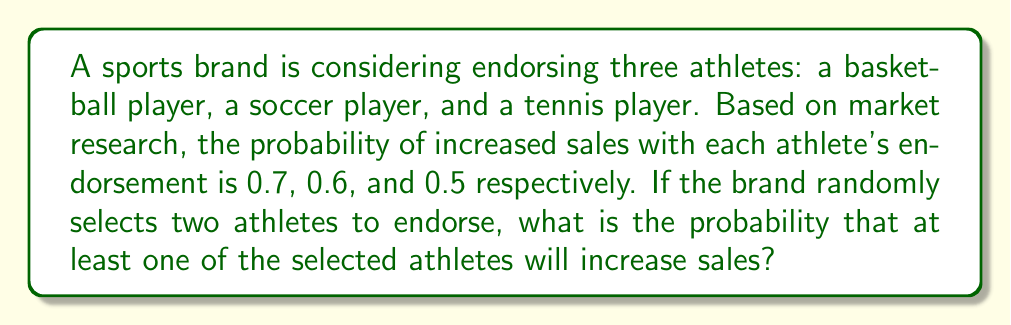Can you answer this question? Let's approach this step-by-step:

1) First, we need to calculate the probability of selecting any two athletes out of the three. This is a combination problem, but since we're selecting 2 out of 3, there are only 3 possible combinations:
   (basketball, soccer), (basketball, tennis), (soccer, tennis)

2) Now, let's calculate the probability of increased sales for each combination:

   a) For (basketball, soccer):
      P(at least one increases sales) = 1 - P(neither increases sales)
      = 1 - (1-0.7)(1-0.6) = 1 - 0.3 * 0.4 = 1 - 0.12 = 0.88

   b) For (basketball, tennis):
      P(at least one increases sales) = 1 - P(neither increases sales)
      = 1 - (1-0.7)(1-0.5) = 1 - 0.3 * 0.5 = 1 - 0.15 = 0.85

   c) For (soccer, tennis):
      P(at least one increases sales) = 1 - P(neither increases sales)
      = 1 - (1-0.6)(1-0.5) = 1 - 0.4 * 0.5 = 1 - 0.20 = 0.80

3) Since each combination has an equal probability of being selected (1/3), we can calculate the overall probability by taking the average of these three probabilities:

   $$P(\text{at least one athlete increases sales}) = \frac{0.88 + 0.85 + 0.80}{3} = \frac{2.53}{3} \approx 0.8433$$

4) Therefore, the probability that at least one of the two randomly selected athletes will increase sales is approximately 0.8433 or 84.33%.
Answer: 0.8433 